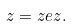<formula> <loc_0><loc_0><loc_500><loc_500>z = z e z .</formula> 